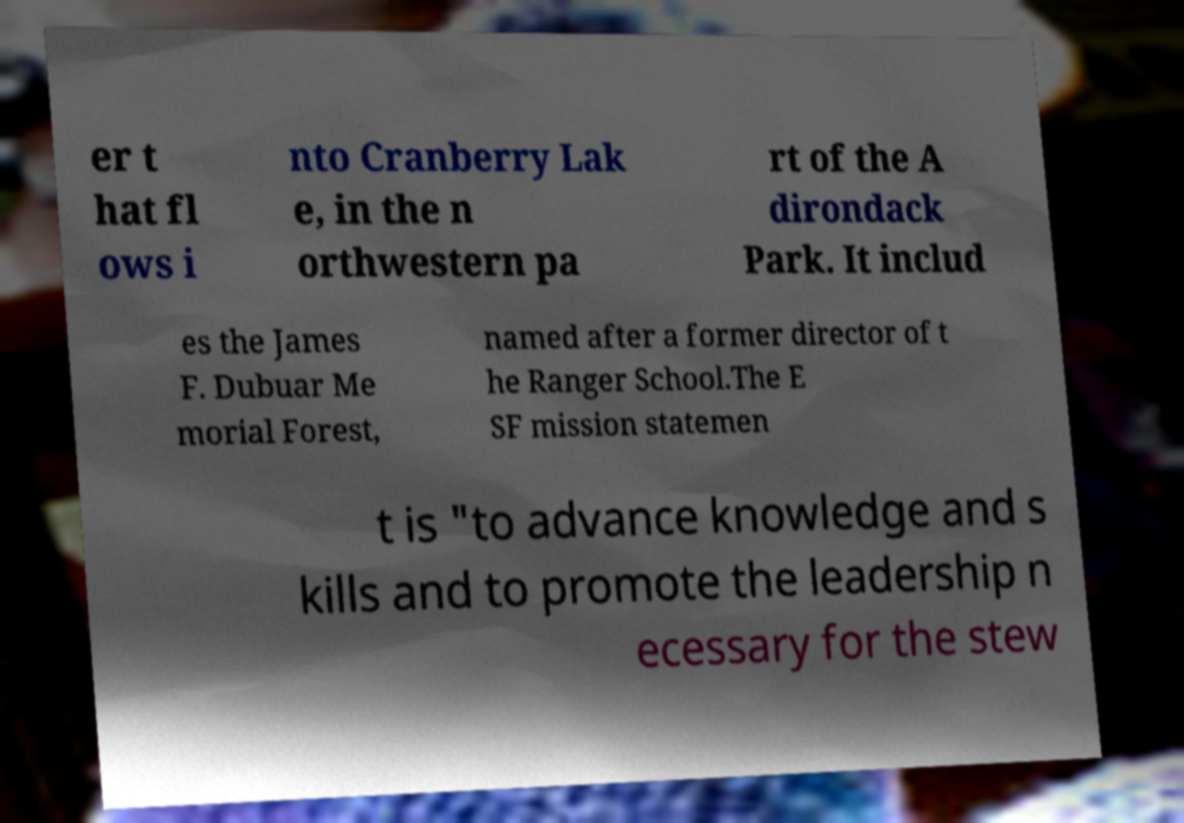Please identify and transcribe the text found in this image. er t hat fl ows i nto Cranberry Lak e, in the n orthwestern pa rt of the A dirondack Park. It includ es the James F. Dubuar Me morial Forest, named after a former director of t he Ranger School.The E SF mission statemen t is "to advance knowledge and s kills and to promote the leadership n ecessary for the stew 